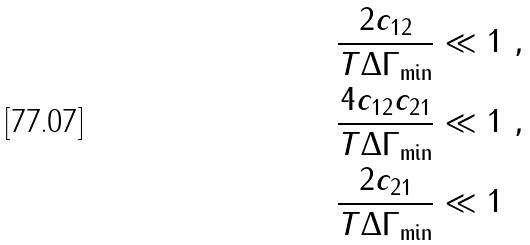<formula> <loc_0><loc_0><loc_500><loc_500>\frac { 2 c _ { 1 2 } } { T \Delta \Gamma _ { \min } } & \ll 1 \ , \\ \frac { 4 c _ { 1 2 } c _ { 2 1 } } { T \Delta \Gamma _ { \min } } & \ll 1 \ , \\ \frac { 2 c _ { 2 1 } } { T \Delta \Gamma _ { \min } } & \ll 1</formula> 